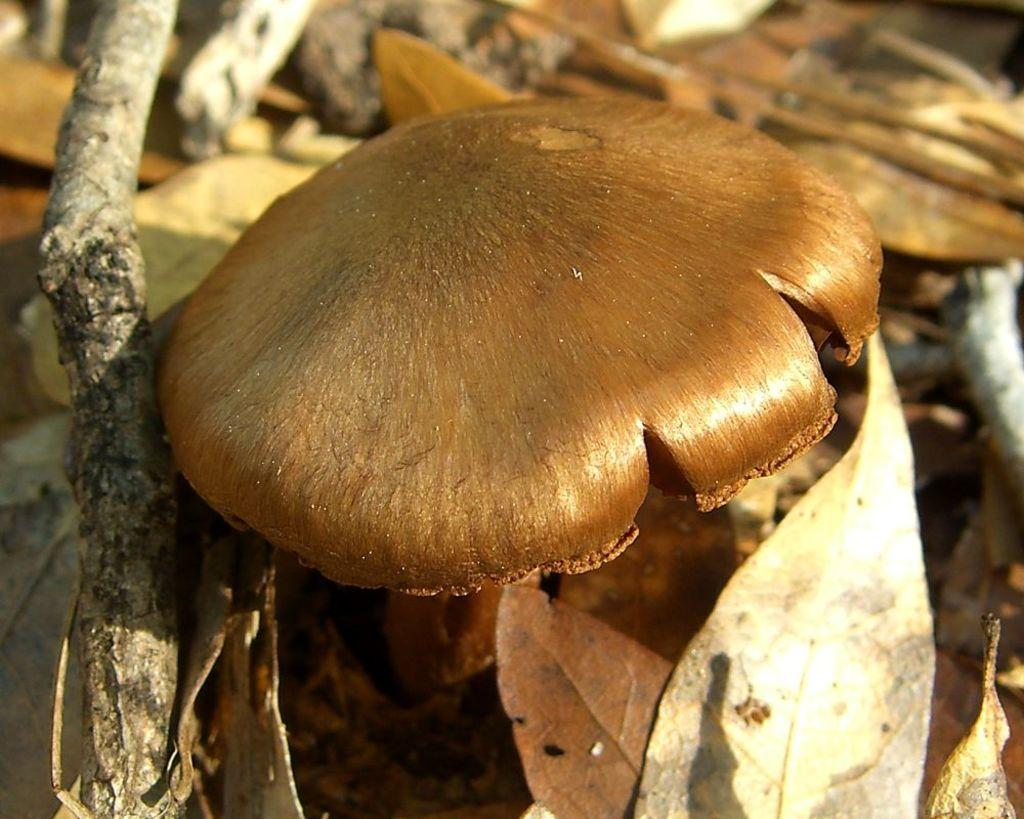What type of fungus can be seen in the image? There is a mushroom in the image. What type of plant material is present in the image? There are dried leaves in the image. How does the man transport the mushroom and dried leaves in the image? There is no man present in the image, so it is not possible to answer this question. 